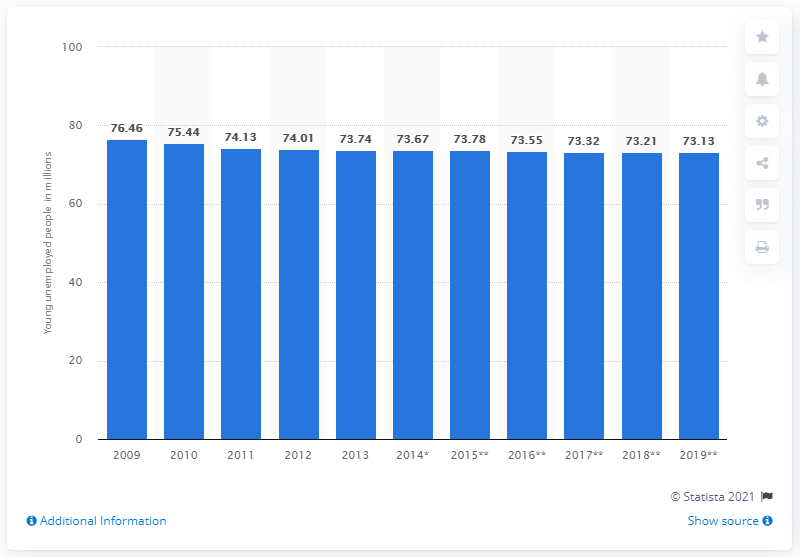Indicate a few pertinent items in this graphic. In 2012, there were 73.32 unemployed young people. 